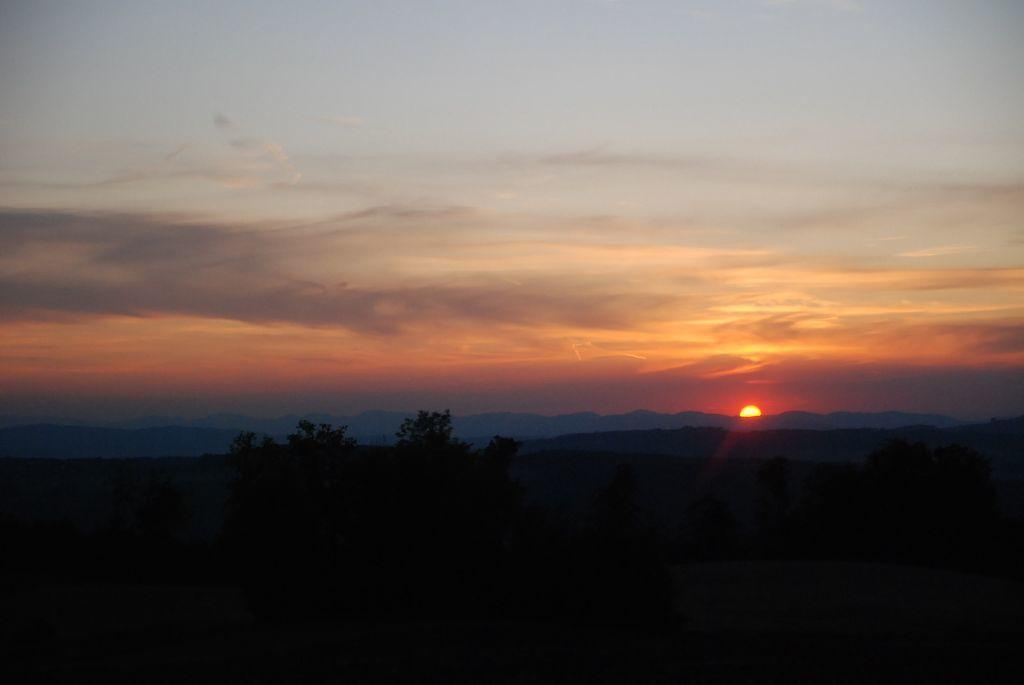What type of natural environment is depicted in the image? The image contains many trees, mountains, and clouds in the background. What is visible in the distance behind the trees? There are mountains in the background of the image. What can be seen in the sky in the image? The sky is visible in the background of the image, and the sun is observable. How many celestial bodies are visible in the sky? One celestial body, the sun, is visible in the sky. What type of coat is hanging on the tree in the image? There is no coat present in the image; it features trees, mountains, clouds, and the sky. What type of cracker is being used to create the clouds in the image? The clouds in the image are natural formations and are not created by crackers. 